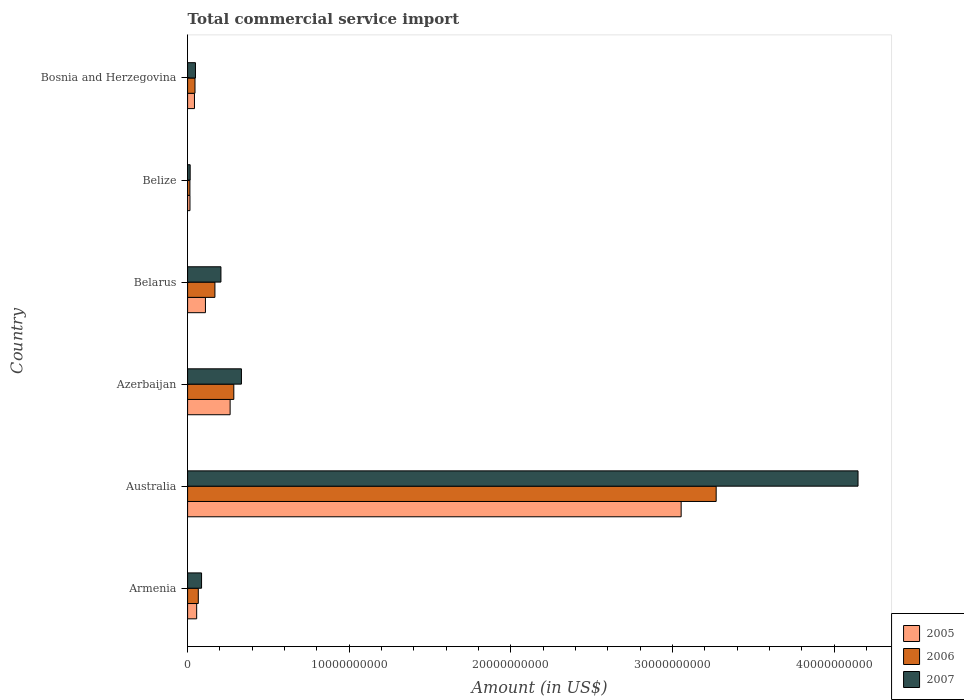How many different coloured bars are there?
Provide a short and direct response. 3. How many groups of bars are there?
Offer a very short reply. 6. Are the number of bars per tick equal to the number of legend labels?
Ensure brevity in your answer.  Yes. What is the label of the 4th group of bars from the top?
Your answer should be very brief. Azerbaijan. What is the total commercial service import in 2005 in Belize?
Make the answer very short. 1.47e+08. Across all countries, what is the maximum total commercial service import in 2007?
Keep it short and to the point. 4.15e+1. Across all countries, what is the minimum total commercial service import in 2006?
Your answer should be compact. 1.43e+08. In which country was the total commercial service import in 2005 minimum?
Provide a succinct answer. Belize. What is the total total commercial service import in 2005 in the graph?
Ensure brevity in your answer.  3.54e+1. What is the difference between the total commercial service import in 2007 in Belarus and that in Belize?
Your response must be concise. 1.90e+09. What is the difference between the total commercial service import in 2007 in Belarus and the total commercial service import in 2006 in Australia?
Offer a terse response. -3.06e+1. What is the average total commercial service import in 2007 per country?
Your answer should be compact. 8.06e+09. What is the difference between the total commercial service import in 2005 and total commercial service import in 2007 in Belize?
Offer a terse response. -1.18e+07. What is the ratio of the total commercial service import in 2007 in Armenia to that in Bosnia and Herzegovina?
Make the answer very short. 1.78. Is the total commercial service import in 2006 in Armenia less than that in Australia?
Your answer should be compact. Yes. What is the difference between the highest and the second highest total commercial service import in 2005?
Your answer should be very brief. 2.79e+1. What is the difference between the highest and the lowest total commercial service import in 2005?
Give a very brief answer. 3.04e+1. In how many countries, is the total commercial service import in 2007 greater than the average total commercial service import in 2007 taken over all countries?
Make the answer very short. 1. What does the 1st bar from the top in Bosnia and Herzegovina represents?
Your answer should be compact. 2007. What does the 2nd bar from the bottom in Australia represents?
Offer a terse response. 2006. Is it the case that in every country, the sum of the total commercial service import in 2007 and total commercial service import in 2006 is greater than the total commercial service import in 2005?
Your response must be concise. Yes. Are all the bars in the graph horizontal?
Provide a succinct answer. Yes. How many countries are there in the graph?
Provide a succinct answer. 6. What is the difference between two consecutive major ticks on the X-axis?
Provide a succinct answer. 1.00e+1. Are the values on the major ticks of X-axis written in scientific E-notation?
Make the answer very short. No. Does the graph contain grids?
Make the answer very short. No. How many legend labels are there?
Your answer should be very brief. 3. How are the legend labels stacked?
Make the answer very short. Vertical. What is the title of the graph?
Ensure brevity in your answer.  Total commercial service import. Does "1965" appear as one of the legend labels in the graph?
Offer a very short reply. No. What is the label or title of the Y-axis?
Ensure brevity in your answer.  Country. What is the Amount (in US$) in 2005 in Armenia?
Ensure brevity in your answer.  5.61e+08. What is the Amount (in US$) of 2006 in Armenia?
Make the answer very short. 6.62e+08. What is the Amount (in US$) in 2007 in Armenia?
Provide a succinct answer. 8.64e+08. What is the Amount (in US$) in 2005 in Australia?
Ensure brevity in your answer.  3.05e+1. What is the Amount (in US$) of 2006 in Australia?
Your response must be concise. 3.27e+1. What is the Amount (in US$) in 2007 in Australia?
Provide a short and direct response. 4.15e+1. What is the Amount (in US$) of 2005 in Azerbaijan?
Give a very brief answer. 2.63e+09. What is the Amount (in US$) of 2006 in Azerbaijan?
Offer a very short reply. 2.86e+09. What is the Amount (in US$) in 2007 in Azerbaijan?
Your response must be concise. 3.33e+09. What is the Amount (in US$) of 2005 in Belarus?
Your response must be concise. 1.10e+09. What is the Amount (in US$) in 2006 in Belarus?
Give a very brief answer. 1.69e+09. What is the Amount (in US$) in 2007 in Belarus?
Your response must be concise. 2.06e+09. What is the Amount (in US$) of 2005 in Belize?
Give a very brief answer. 1.47e+08. What is the Amount (in US$) of 2006 in Belize?
Offer a terse response. 1.43e+08. What is the Amount (in US$) in 2007 in Belize?
Your answer should be compact. 1.59e+08. What is the Amount (in US$) in 2005 in Bosnia and Herzegovina?
Ensure brevity in your answer.  4.25e+08. What is the Amount (in US$) in 2006 in Bosnia and Herzegovina?
Provide a succinct answer. 4.58e+08. What is the Amount (in US$) of 2007 in Bosnia and Herzegovina?
Keep it short and to the point. 4.87e+08. Across all countries, what is the maximum Amount (in US$) in 2005?
Provide a short and direct response. 3.05e+1. Across all countries, what is the maximum Amount (in US$) of 2006?
Offer a very short reply. 3.27e+1. Across all countries, what is the maximum Amount (in US$) of 2007?
Make the answer very short. 4.15e+1. Across all countries, what is the minimum Amount (in US$) of 2005?
Ensure brevity in your answer.  1.47e+08. Across all countries, what is the minimum Amount (in US$) of 2006?
Make the answer very short. 1.43e+08. Across all countries, what is the minimum Amount (in US$) of 2007?
Provide a short and direct response. 1.59e+08. What is the total Amount (in US$) of 2005 in the graph?
Offer a terse response. 3.54e+1. What is the total Amount (in US$) of 2006 in the graph?
Your answer should be very brief. 3.85e+1. What is the total Amount (in US$) in 2007 in the graph?
Provide a short and direct response. 4.84e+1. What is the difference between the Amount (in US$) of 2005 in Armenia and that in Australia?
Keep it short and to the point. -3.00e+1. What is the difference between the Amount (in US$) in 2006 in Armenia and that in Australia?
Give a very brief answer. -3.20e+1. What is the difference between the Amount (in US$) of 2007 in Armenia and that in Australia?
Your response must be concise. -4.06e+1. What is the difference between the Amount (in US$) of 2005 in Armenia and that in Azerbaijan?
Keep it short and to the point. -2.07e+09. What is the difference between the Amount (in US$) in 2006 in Armenia and that in Azerbaijan?
Offer a very short reply. -2.20e+09. What is the difference between the Amount (in US$) of 2007 in Armenia and that in Azerbaijan?
Keep it short and to the point. -2.47e+09. What is the difference between the Amount (in US$) of 2005 in Armenia and that in Belarus?
Offer a terse response. -5.43e+08. What is the difference between the Amount (in US$) in 2006 in Armenia and that in Belarus?
Provide a short and direct response. -1.03e+09. What is the difference between the Amount (in US$) of 2007 in Armenia and that in Belarus?
Provide a short and direct response. -1.20e+09. What is the difference between the Amount (in US$) of 2005 in Armenia and that in Belize?
Keep it short and to the point. 4.14e+08. What is the difference between the Amount (in US$) in 2006 in Armenia and that in Belize?
Offer a very short reply. 5.19e+08. What is the difference between the Amount (in US$) of 2007 in Armenia and that in Belize?
Offer a terse response. 7.05e+08. What is the difference between the Amount (in US$) of 2005 in Armenia and that in Bosnia and Herzegovina?
Ensure brevity in your answer.  1.37e+08. What is the difference between the Amount (in US$) in 2006 in Armenia and that in Bosnia and Herzegovina?
Your answer should be compact. 2.04e+08. What is the difference between the Amount (in US$) in 2007 in Armenia and that in Bosnia and Herzegovina?
Your answer should be very brief. 3.78e+08. What is the difference between the Amount (in US$) in 2005 in Australia and that in Azerbaijan?
Offer a terse response. 2.79e+1. What is the difference between the Amount (in US$) of 2006 in Australia and that in Azerbaijan?
Your response must be concise. 2.98e+1. What is the difference between the Amount (in US$) in 2007 in Australia and that in Azerbaijan?
Make the answer very short. 3.81e+1. What is the difference between the Amount (in US$) in 2005 in Australia and that in Belarus?
Your response must be concise. 2.94e+1. What is the difference between the Amount (in US$) in 2006 in Australia and that in Belarus?
Offer a terse response. 3.10e+1. What is the difference between the Amount (in US$) of 2007 in Australia and that in Belarus?
Provide a short and direct response. 3.94e+1. What is the difference between the Amount (in US$) of 2005 in Australia and that in Belize?
Your response must be concise. 3.04e+1. What is the difference between the Amount (in US$) in 2006 in Australia and that in Belize?
Make the answer very short. 3.26e+1. What is the difference between the Amount (in US$) in 2007 in Australia and that in Belize?
Your response must be concise. 4.13e+1. What is the difference between the Amount (in US$) of 2005 in Australia and that in Bosnia and Herzegovina?
Keep it short and to the point. 3.01e+1. What is the difference between the Amount (in US$) in 2006 in Australia and that in Bosnia and Herzegovina?
Offer a terse response. 3.22e+1. What is the difference between the Amount (in US$) of 2007 in Australia and that in Bosnia and Herzegovina?
Keep it short and to the point. 4.10e+1. What is the difference between the Amount (in US$) of 2005 in Azerbaijan and that in Belarus?
Your answer should be very brief. 1.53e+09. What is the difference between the Amount (in US$) in 2006 in Azerbaijan and that in Belarus?
Offer a terse response. 1.17e+09. What is the difference between the Amount (in US$) of 2007 in Azerbaijan and that in Belarus?
Make the answer very short. 1.27e+09. What is the difference between the Amount (in US$) in 2005 in Azerbaijan and that in Belize?
Make the answer very short. 2.48e+09. What is the difference between the Amount (in US$) of 2006 in Azerbaijan and that in Belize?
Give a very brief answer. 2.72e+09. What is the difference between the Amount (in US$) in 2007 in Azerbaijan and that in Belize?
Offer a terse response. 3.17e+09. What is the difference between the Amount (in US$) in 2005 in Azerbaijan and that in Bosnia and Herzegovina?
Provide a succinct answer. 2.21e+09. What is the difference between the Amount (in US$) in 2006 in Azerbaijan and that in Bosnia and Herzegovina?
Offer a very short reply. 2.40e+09. What is the difference between the Amount (in US$) in 2007 in Azerbaijan and that in Bosnia and Herzegovina?
Keep it short and to the point. 2.84e+09. What is the difference between the Amount (in US$) in 2005 in Belarus and that in Belize?
Keep it short and to the point. 9.57e+08. What is the difference between the Amount (in US$) in 2006 in Belarus and that in Belize?
Provide a succinct answer. 1.55e+09. What is the difference between the Amount (in US$) of 2007 in Belarus and that in Belize?
Your answer should be very brief. 1.90e+09. What is the difference between the Amount (in US$) of 2005 in Belarus and that in Bosnia and Herzegovina?
Keep it short and to the point. 6.79e+08. What is the difference between the Amount (in US$) of 2006 in Belarus and that in Bosnia and Herzegovina?
Provide a short and direct response. 1.23e+09. What is the difference between the Amount (in US$) of 2007 in Belarus and that in Bosnia and Herzegovina?
Your answer should be very brief. 1.58e+09. What is the difference between the Amount (in US$) of 2005 in Belize and that in Bosnia and Herzegovina?
Keep it short and to the point. -2.78e+08. What is the difference between the Amount (in US$) in 2006 in Belize and that in Bosnia and Herzegovina?
Offer a terse response. -3.15e+08. What is the difference between the Amount (in US$) in 2007 in Belize and that in Bosnia and Herzegovina?
Offer a terse response. -3.28e+08. What is the difference between the Amount (in US$) of 2005 in Armenia and the Amount (in US$) of 2006 in Australia?
Keep it short and to the point. -3.21e+1. What is the difference between the Amount (in US$) in 2005 in Armenia and the Amount (in US$) in 2007 in Australia?
Keep it short and to the point. -4.09e+1. What is the difference between the Amount (in US$) in 2006 in Armenia and the Amount (in US$) in 2007 in Australia?
Your response must be concise. -4.08e+1. What is the difference between the Amount (in US$) of 2005 in Armenia and the Amount (in US$) of 2006 in Azerbaijan?
Keep it short and to the point. -2.30e+09. What is the difference between the Amount (in US$) in 2005 in Armenia and the Amount (in US$) in 2007 in Azerbaijan?
Keep it short and to the point. -2.77e+09. What is the difference between the Amount (in US$) in 2006 in Armenia and the Amount (in US$) in 2007 in Azerbaijan?
Your response must be concise. -2.67e+09. What is the difference between the Amount (in US$) of 2005 in Armenia and the Amount (in US$) of 2006 in Belarus?
Your answer should be compact. -1.13e+09. What is the difference between the Amount (in US$) in 2005 in Armenia and the Amount (in US$) in 2007 in Belarus?
Your answer should be compact. -1.50e+09. What is the difference between the Amount (in US$) of 2006 in Armenia and the Amount (in US$) of 2007 in Belarus?
Your answer should be compact. -1.40e+09. What is the difference between the Amount (in US$) in 2005 in Armenia and the Amount (in US$) in 2006 in Belize?
Provide a short and direct response. 4.18e+08. What is the difference between the Amount (in US$) of 2005 in Armenia and the Amount (in US$) of 2007 in Belize?
Offer a terse response. 4.02e+08. What is the difference between the Amount (in US$) in 2006 in Armenia and the Amount (in US$) in 2007 in Belize?
Keep it short and to the point. 5.03e+08. What is the difference between the Amount (in US$) in 2005 in Armenia and the Amount (in US$) in 2006 in Bosnia and Herzegovina?
Provide a succinct answer. 1.03e+08. What is the difference between the Amount (in US$) of 2005 in Armenia and the Amount (in US$) of 2007 in Bosnia and Herzegovina?
Offer a terse response. 7.47e+07. What is the difference between the Amount (in US$) in 2006 in Armenia and the Amount (in US$) in 2007 in Bosnia and Herzegovina?
Your response must be concise. 1.76e+08. What is the difference between the Amount (in US$) in 2005 in Australia and the Amount (in US$) in 2006 in Azerbaijan?
Your response must be concise. 2.77e+1. What is the difference between the Amount (in US$) of 2005 in Australia and the Amount (in US$) of 2007 in Azerbaijan?
Offer a terse response. 2.72e+1. What is the difference between the Amount (in US$) of 2006 in Australia and the Amount (in US$) of 2007 in Azerbaijan?
Your answer should be compact. 2.94e+1. What is the difference between the Amount (in US$) of 2005 in Australia and the Amount (in US$) of 2006 in Belarus?
Give a very brief answer. 2.88e+1. What is the difference between the Amount (in US$) of 2005 in Australia and the Amount (in US$) of 2007 in Belarus?
Keep it short and to the point. 2.85e+1. What is the difference between the Amount (in US$) of 2006 in Australia and the Amount (in US$) of 2007 in Belarus?
Your answer should be compact. 3.06e+1. What is the difference between the Amount (in US$) in 2005 in Australia and the Amount (in US$) in 2006 in Belize?
Offer a very short reply. 3.04e+1. What is the difference between the Amount (in US$) of 2005 in Australia and the Amount (in US$) of 2007 in Belize?
Provide a short and direct response. 3.04e+1. What is the difference between the Amount (in US$) of 2006 in Australia and the Amount (in US$) of 2007 in Belize?
Your answer should be compact. 3.25e+1. What is the difference between the Amount (in US$) of 2005 in Australia and the Amount (in US$) of 2006 in Bosnia and Herzegovina?
Your response must be concise. 3.01e+1. What is the difference between the Amount (in US$) in 2005 in Australia and the Amount (in US$) in 2007 in Bosnia and Herzegovina?
Make the answer very short. 3.00e+1. What is the difference between the Amount (in US$) of 2006 in Australia and the Amount (in US$) of 2007 in Bosnia and Herzegovina?
Your answer should be very brief. 3.22e+1. What is the difference between the Amount (in US$) of 2005 in Azerbaijan and the Amount (in US$) of 2006 in Belarus?
Your answer should be compact. 9.40e+08. What is the difference between the Amount (in US$) of 2005 in Azerbaijan and the Amount (in US$) of 2007 in Belarus?
Your answer should be compact. 5.68e+08. What is the difference between the Amount (in US$) of 2006 in Azerbaijan and the Amount (in US$) of 2007 in Belarus?
Provide a succinct answer. 7.97e+08. What is the difference between the Amount (in US$) of 2005 in Azerbaijan and the Amount (in US$) of 2006 in Belize?
Your answer should be compact. 2.49e+09. What is the difference between the Amount (in US$) in 2005 in Azerbaijan and the Amount (in US$) in 2007 in Belize?
Your response must be concise. 2.47e+09. What is the difference between the Amount (in US$) of 2006 in Azerbaijan and the Amount (in US$) of 2007 in Belize?
Offer a terse response. 2.70e+09. What is the difference between the Amount (in US$) in 2005 in Azerbaijan and the Amount (in US$) in 2006 in Bosnia and Herzegovina?
Offer a very short reply. 2.17e+09. What is the difference between the Amount (in US$) in 2005 in Azerbaijan and the Amount (in US$) in 2007 in Bosnia and Herzegovina?
Offer a very short reply. 2.14e+09. What is the difference between the Amount (in US$) of 2006 in Azerbaijan and the Amount (in US$) of 2007 in Bosnia and Herzegovina?
Offer a very short reply. 2.37e+09. What is the difference between the Amount (in US$) in 2005 in Belarus and the Amount (in US$) in 2006 in Belize?
Provide a succinct answer. 9.61e+08. What is the difference between the Amount (in US$) of 2005 in Belarus and the Amount (in US$) of 2007 in Belize?
Make the answer very short. 9.45e+08. What is the difference between the Amount (in US$) of 2006 in Belarus and the Amount (in US$) of 2007 in Belize?
Offer a very short reply. 1.53e+09. What is the difference between the Amount (in US$) of 2005 in Belarus and the Amount (in US$) of 2006 in Bosnia and Herzegovina?
Provide a succinct answer. 6.46e+08. What is the difference between the Amount (in US$) in 2005 in Belarus and the Amount (in US$) in 2007 in Bosnia and Herzegovina?
Your response must be concise. 6.18e+08. What is the difference between the Amount (in US$) of 2006 in Belarus and the Amount (in US$) of 2007 in Bosnia and Herzegovina?
Keep it short and to the point. 1.20e+09. What is the difference between the Amount (in US$) of 2005 in Belize and the Amount (in US$) of 2006 in Bosnia and Herzegovina?
Your answer should be very brief. -3.11e+08. What is the difference between the Amount (in US$) in 2005 in Belize and the Amount (in US$) in 2007 in Bosnia and Herzegovina?
Give a very brief answer. -3.39e+08. What is the difference between the Amount (in US$) of 2006 in Belize and the Amount (in US$) of 2007 in Bosnia and Herzegovina?
Your answer should be compact. -3.43e+08. What is the average Amount (in US$) in 2005 per country?
Provide a succinct answer. 5.90e+09. What is the average Amount (in US$) in 2006 per country?
Ensure brevity in your answer.  6.42e+09. What is the average Amount (in US$) in 2007 per country?
Provide a succinct answer. 8.06e+09. What is the difference between the Amount (in US$) of 2005 and Amount (in US$) of 2006 in Armenia?
Give a very brief answer. -1.01e+08. What is the difference between the Amount (in US$) of 2005 and Amount (in US$) of 2007 in Armenia?
Your response must be concise. -3.03e+08. What is the difference between the Amount (in US$) in 2006 and Amount (in US$) in 2007 in Armenia?
Make the answer very short. -2.02e+08. What is the difference between the Amount (in US$) of 2005 and Amount (in US$) of 2006 in Australia?
Offer a very short reply. -2.17e+09. What is the difference between the Amount (in US$) of 2005 and Amount (in US$) of 2007 in Australia?
Offer a terse response. -1.09e+1. What is the difference between the Amount (in US$) in 2006 and Amount (in US$) in 2007 in Australia?
Keep it short and to the point. -8.78e+09. What is the difference between the Amount (in US$) of 2005 and Amount (in US$) of 2006 in Azerbaijan?
Give a very brief answer. -2.28e+08. What is the difference between the Amount (in US$) in 2005 and Amount (in US$) in 2007 in Azerbaijan?
Offer a terse response. -7.00e+08. What is the difference between the Amount (in US$) of 2006 and Amount (in US$) of 2007 in Azerbaijan?
Offer a terse response. -4.72e+08. What is the difference between the Amount (in US$) of 2005 and Amount (in US$) of 2006 in Belarus?
Make the answer very short. -5.87e+08. What is the difference between the Amount (in US$) in 2005 and Amount (in US$) in 2007 in Belarus?
Keep it short and to the point. -9.58e+08. What is the difference between the Amount (in US$) in 2006 and Amount (in US$) in 2007 in Belarus?
Your response must be concise. -3.72e+08. What is the difference between the Amount (in US$) in 2005 and Amount (in US$) in 2006 in Belize?
Provide a succinct answer. 3.89e+06. What is the difference between the Amount (in US$) in 2005 and Amount (in US$) in 2007 in Belize?
Offer a terse response. -1.18e+07. What is the difference between the Amount (in US$) of 2006 and Amount (in US$) of 2007 in Belize?
Keep it short and to the point. -1.57e+07. What is the difference between the Amount (in US$) of 2005 and Amount (in US$) of 2006 in Bosnia and Herzegovina?
Offer a very short reply. -3.32e+07. What is the difference between the Amount (in US$) in 2005 and Amount (in US$) in 2007 in Bosnia and Herzegovina?
Give a very brief answer. -6.18e+07. What is the difference between the Amount (in US$) of 2006 and Amount (in US$) of 2007 in Bosnia and Herzegovina?
Your response must be concise. -2.86e+07. What is the ratio of the Amount (in US$) in 2005 in Armenia to that in Australia?
Offer a terse response. 0.02. What is the ratio of the Amount (in US$) of 2006 in Armenia to that in Australia?
Make the answer very short. 0.02. What is the ratio of the Amount (in US$) in 2007 in Armenia to that in Australia?
Give a very brief answer. 0.02. What is the ratio of the Amount (in US$) in 2005 in Armenia to that in Azerbaijan?
Ensure brevity in your answer.  0.21. What is the ratio of the Amount (in US$) in 2006 in Armenia to that in Azerbaijan?
Give a very brief answer. 0.23. What is the ratio of the Amount (in US$) in 2007 in Armenia to that in Azerbaijan?
Your response must be concise. 0.26. What is the ratio of the Amount (in US$) of 2005 in Armenia to that in Belarus?
Provide a short and direct response. 0.51. What is the ratio of the Amount (in US$) of 2006 in Armenia to that in Belarus?
Provide a short and direct response. 0.39. What is the ratio of the Amount (in US$) of 2007 in Armenia to that in Belarus?
Your answer should be very brief. 0.42. What is the ratio of the Amount (in US$) in 2005 in Armenia to that in Belize?
Offer a very short reply. 3.81. What is the ratio of the Amount (in US$) of 2006 in Armenia to that in Belize?
Make the answer very short. 4.62. What is the ratio of the Amount (in US$) in 2007 in Armenia to that in Belize?
Give a very brief answer. 5.44. What is the ratio of the Amount (in US$) of 2005 in Armenia to that in Bosnia and Herzegovina?
Make the answer very short. 1.32. What is the ratio of the Amount (in US$) in 2006 in Armenia to that in Bosnia and Herzegovina?
Ensure brevity in your answer.  1.45. What is the ratio of the Amount (in US$) of 2007 in Armenia to that in Bosnia and Herzegovina?
Make the answer very short. 1.78. What is the ratio of the Amount (in US$) of 2005 in Australia to that in Azerbaijan?
Provide a succinct answer. 11.61. What is the ratio of the Amount (in US$) in 2006 in Australia to that in Azerbaijan?
Give a very brief answer. 11.44. What is the ratio of the Amount (in US$) in 2007 in Australia to that in Azerbaijan?
Offer a terse response. 12.45. What is the ratio of the Amount (in US$) in 2005 in Australia to that in Belarus?
Your answer should be very brief. 27.65. What is the ratio of the Amount (in US$) in 2006 in Australia to that in Belarus?
Ensure brevity in your answer.  19.34. What is the ratio of the Amount (in US$) in 2007 in Australia to that in Belarus?
Ensure brevity in your answer.  20.11. What is the ratio of the Amount (in US$) in 2005 in Australia to that in Belize?
Offer a terse response. 207.45. What is the ratio of the Amount (in US$) of 2006 in Australia to that in Belize?
Offer a terse response. 228.19. What is the ratio of the Amount (in US$) in 2007 in Australia to that in Belize?
Your answer should be very brief. 260.86. What is the ratio of the Amount (in US$) of 2005 in Australia to that in Bosnia and Herzegovina?
Ensure brevity in your answer.  71.87. What is the ratio of the Amount (in US$) in 2006 in Australia to that in Bosnia and Herzegovina?
Provide a succinct answer. 71.39. What is the ratio of the Amount (in US$) in 2007 in Australia to that in Bosnia and Herzegovina?
Your answer should be compact. 85.23. What is the ratio of the Amount (in US$) of 2005 in Azerbaijan to that in Belarus?
Ensure brevity in your answer.  2.38. What is the ratio of the Amount (in US$) of 2006 in Azerbaijan to that in Belarus?
Your response must be concise. 1.69. What is the ratio of the Amount (in US$) of 2007 in Azerbaijan to that in Belarus?
Make the answer very short. 1.61. What is the ratio of the Amount (in US$) in 2005 in Azerbaijan to that in Belize?
Provide a succinct answer. 17.87. What is the ratio of the Amount (in US$) in 2006 in Azerbaijan to that in Belize?
Your answer should be compact. 19.95. What is the ratio of the Amount (in US$) of 2007 in Azerbaijan to that in Belize?
Make the answer very short. 20.95. What is the ratio of the Amount (in US$) of 2005 in Azerbaijan to that in Bosnia and Herzegovina?
Offer a very short reply. 6.19. What is the ratio of the Amount (in US$) in 2006 in Azerbaijan to that in Bosnia and Herzegovina?
Ensure brevity in your answer.  6.24. What is the ratio of the Amount (in US$) of 2007 in Azerbaijan to that in Bosnia and Herzegovina?
Offer a very short reply. 6.85. What is the ratio of the Amount (in US$) in 2005 in Belarus to that in Belize?
Provide a succinct answer. 7.5. What is the ratio of the Amount (in US$) in 2006 in Belarus to that in Belize?
Offer a terse response. 11.8. What is the ratio of the Amount (in US$) in 2007 in Belarus to that in Belize?
Make the answer very short. 12.97. What is the ratio of the Amount (in US$) of 2005 in Belarus to that in Bosnia and Herzegovina?
Make the answer very short. 2.6. What is the ratio of the Amount (in US$) in 2006 in Belarus to that in Bosnia and Herzegovina?
Your answer should be compact. 3.69. What is the ratio of the Amount (in US$) in 2007 in Belarus to that in Bosnia and Herzegovina?
Provide a short and direct response. 4.24. What is the ratio of the Amount (in US$) of 2005 in Belize to that in Bosnia and Herzegovina?
Your response must be concise. 0.35. What is the ratio of the Amount (in US$) in 2006 in Belize to that in Bosnia and Herzegovina?
Ensure brevity in your answer.  0.31. What is the ratio of the Amount (in US$) in 2007 in Belize to that in Bosnia and Herzegovina?
Your response must be concise. 0.33. What is the difference between the highest and the second highest Amount (in US$) in 2005?
Provide a short and direct response. 2.79e+1. What is the difference between the highest and the second highest Amount (in US$) of 2006?
Make the answer very short. 2.98e+1. What is the difference between the highest and the second highest Amount (in US$) of 2007?
Give a very brief answer. 3.81e+1. What is the difference between the highest and the lowest Amount (in US$) in 2005?
Keep it short and to the point. 3.04e+1. What is the difference between the highest and the lowest Amount (in US$) in 2006?
Provide a short and direct response. 3.26e+1. What is the difference between the highest and the lowest Amount (in US$) of 2007?
Offer a terse response. 4.13e+1. 